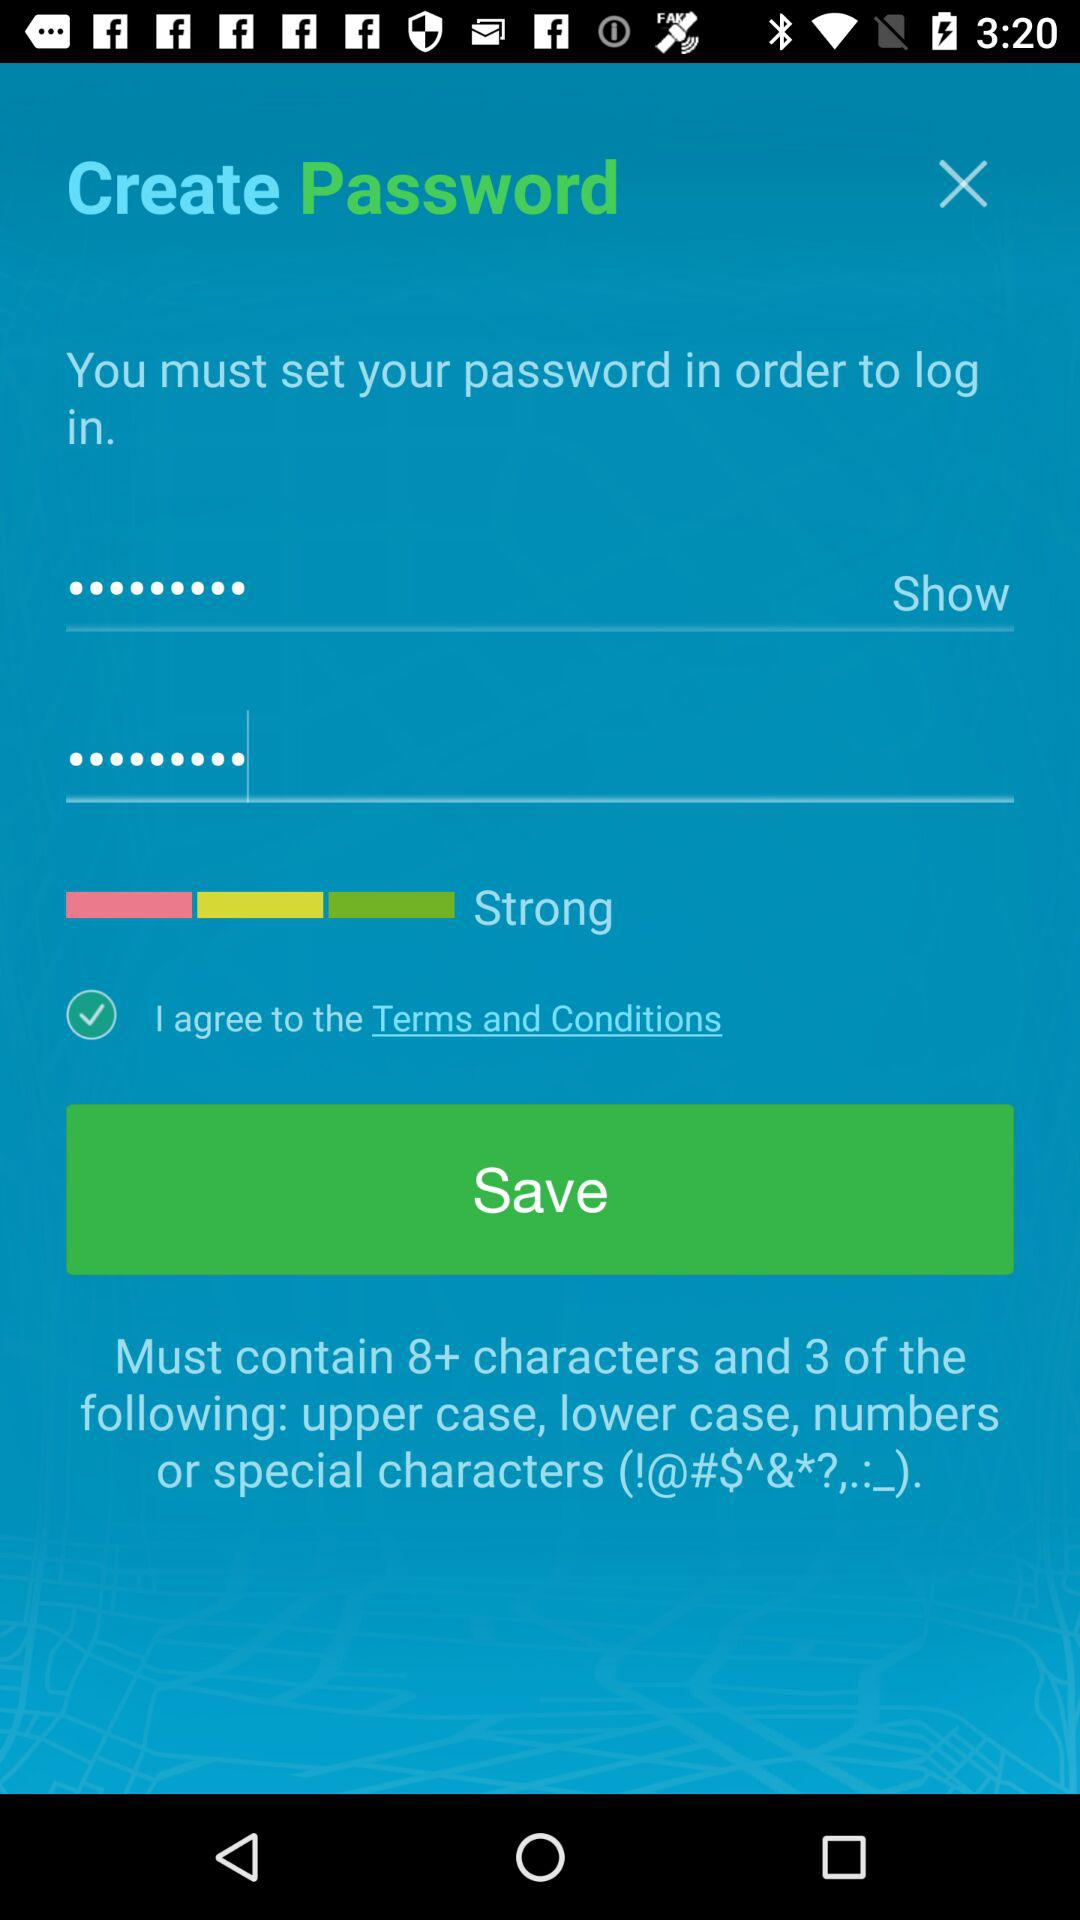What is the status of terms and conditions? The status of the terms and conditions is on. 